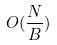<formula> <loc_0><loc_0><loc_500><loc_500>O ( \frac { N } { B } )</formula> 